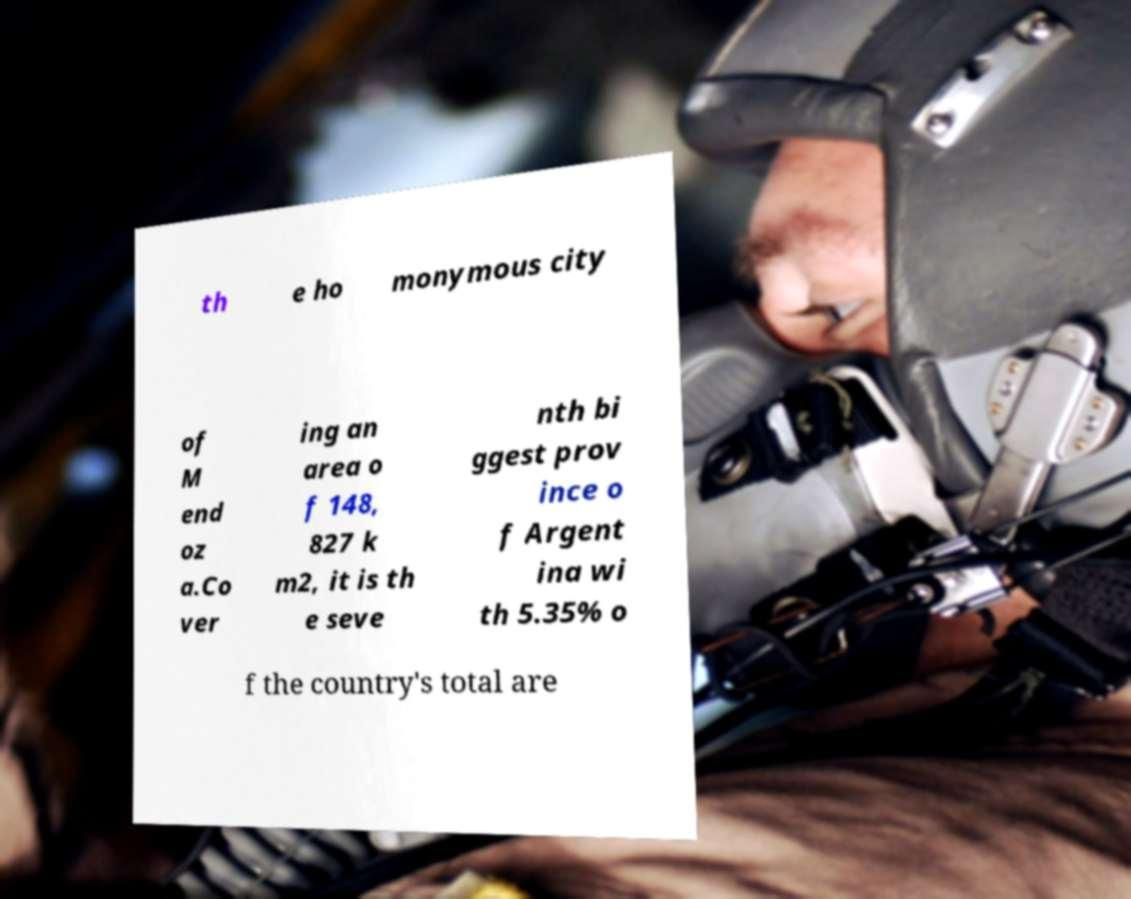For documentation purposes, I need the text within this image transcribed. Could you provide that? th e ho monymous city of M end oz a.Co ver ing an area o f 148, 827 k m2, it is th e seve nth bi ggest prov ince o f Argent ina wi th 5.35% o f the country's total are 